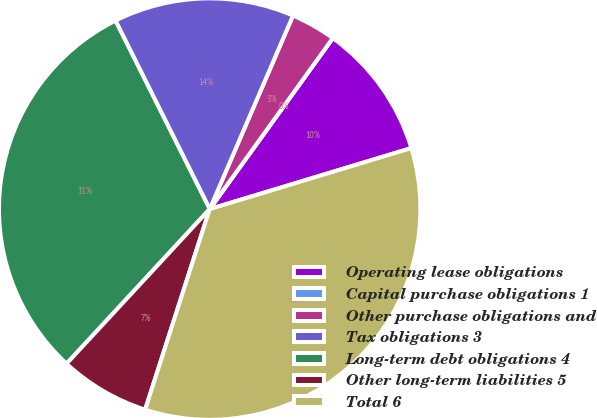<chart> <loc_0><loc_0><loc_500><loc_500><pie_chart><fcel>Operating lease obligations<fcel>Capital purchase obligations 1<fcel>Other purchase obligations and<fcel>Tax obligations 3<fcel>Long-term debt obligations 4<fcel>Other long-term liabilities 5<fcel>Total 6<nl><fcel>10.39%<fcel>0.0%<fcel>3.46%<fcel>13.85%<fcel>30.73%<fcel>6.93%<fcel>34.63%<nl></chart> 